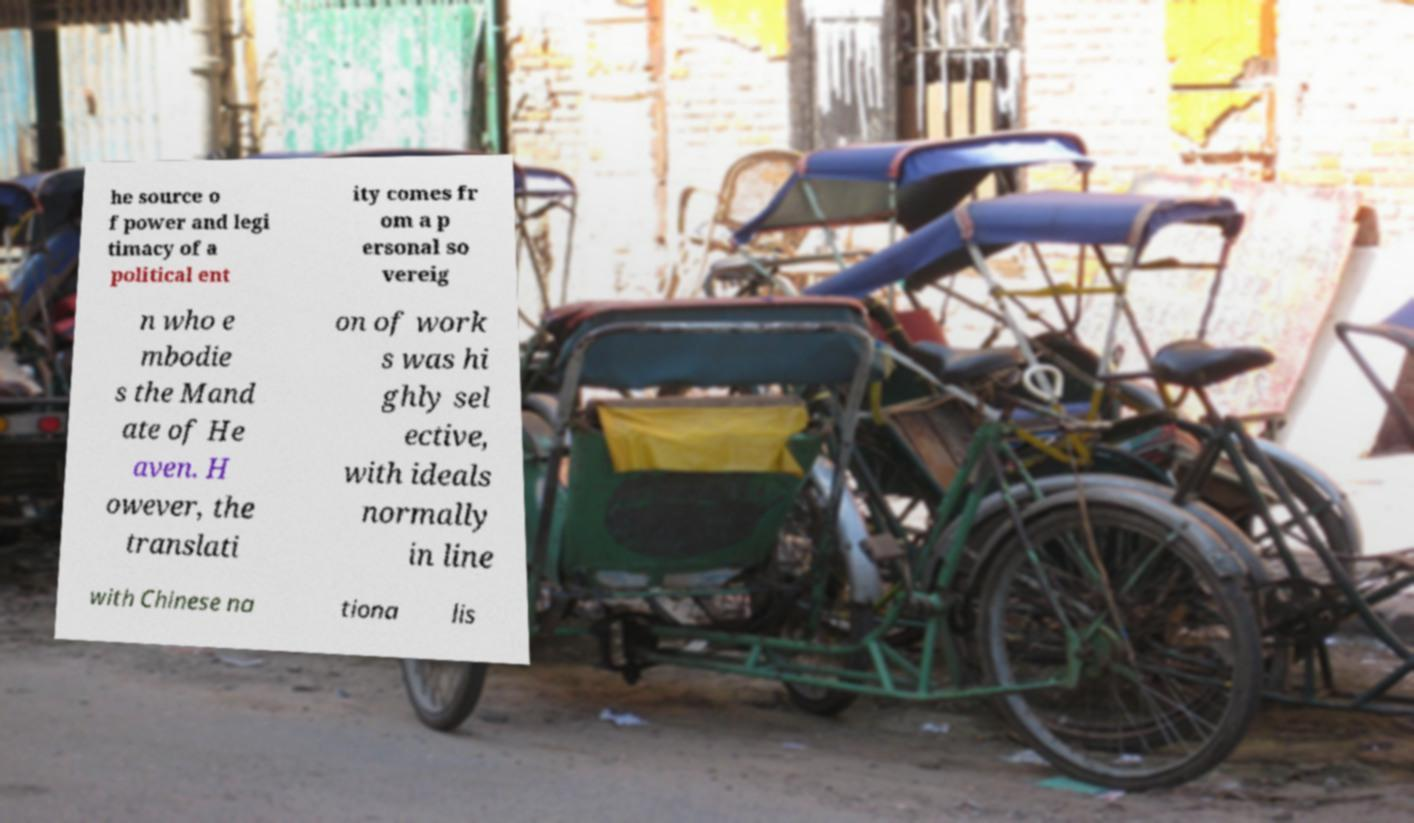I need the written content from this picture converted into text. Can you do that? he source o f power and legi timacy of a political ent ity comes fr om a p ersonal so vereig n who e mbodie s the Mand ate of He aven. H owever, the translati on of work s was hi ghly sel ective, with ideals normally in line with Chinese na tiona lis 